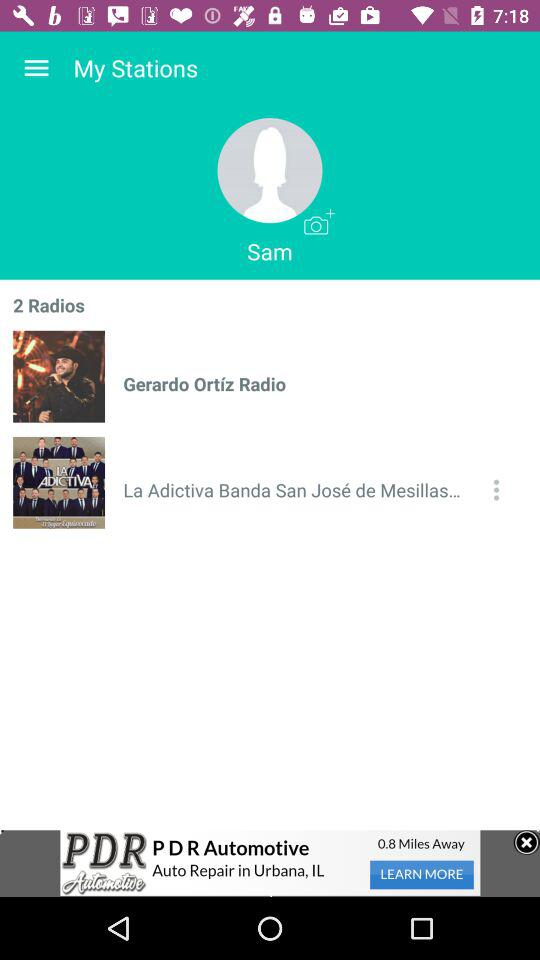What is the name of the radio stations? The names of the radio stations are "Gerardo Ortíz Radio" and "La Adictiva Banda San José de Mesillas...". 